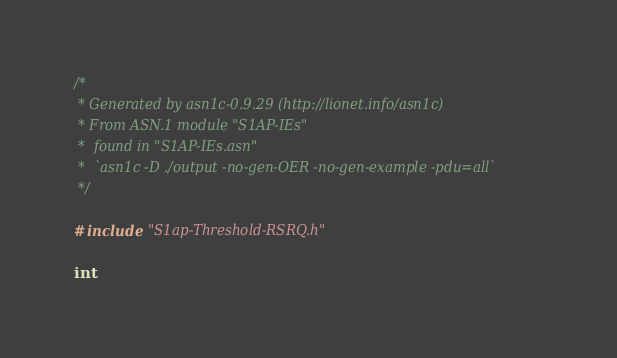Convert code to text. <code><loc_0><loc_0><loc_500><loc_500><_C_>/*
 * Generated by asn1c-0.9.29 (http://lionet.info/asn1c)
 * From ASN.1 module "S1AP-IEs"
 * 	found in "S1AP-IEs.asn"
 * 	`asn1c -D ./output -no-gen-OER -no-gen-example -pdu=all`
 */

#include "S1ap-Threshold-RSRQ.h"

int</code> 